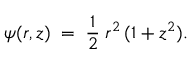Convert formula to latex. <formula><loc_0><loc_0><loc_500><loc_500>\psi ( r , z ) \, = \, \frac { 1 } { 2 } \, r ^ { 2 } \, ( 1 + z ^ { 2 } ) .</formula> 